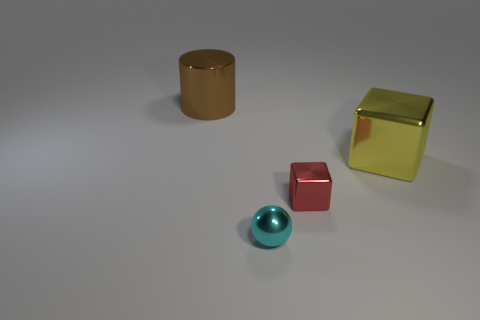What shape is the cyan thing that is the same size as the red object?
Offer a very short reply. Sphere. Is the number of tiny red blocks in front of the red block the same as the number of red cubes behind the large metal cylinder?
Offer a very short reply. Yes. There is a red block in front of the yellow shiny cube that is behind the metallic ball; what is its size?
Ensure brevity in your answer.  Small. Are there any brown things that have the same size as the red shiny thing?
Offer a very short reply. No. What color is the tiny cube that is the same material as the yellow thing?
Give a very brief answer. Red. Are there fewer yellow blocks than small objects?
Your answer should be very brief. Yes. There is a thing that is both behind the red shiny cube and to the left of the big yellow shiny thing; what is its material?
Your response must be concise. Metal. Are there any big cylinders that are on the right side of the large metal object on the right side of the brown cylinder?
Make the answer very short. No. How many large objects are the same color as the small cube?
Provide a short and direct response. 0. Does the tiny red thing have the same material as the cyan object?
Offer a terse response. Yes. 